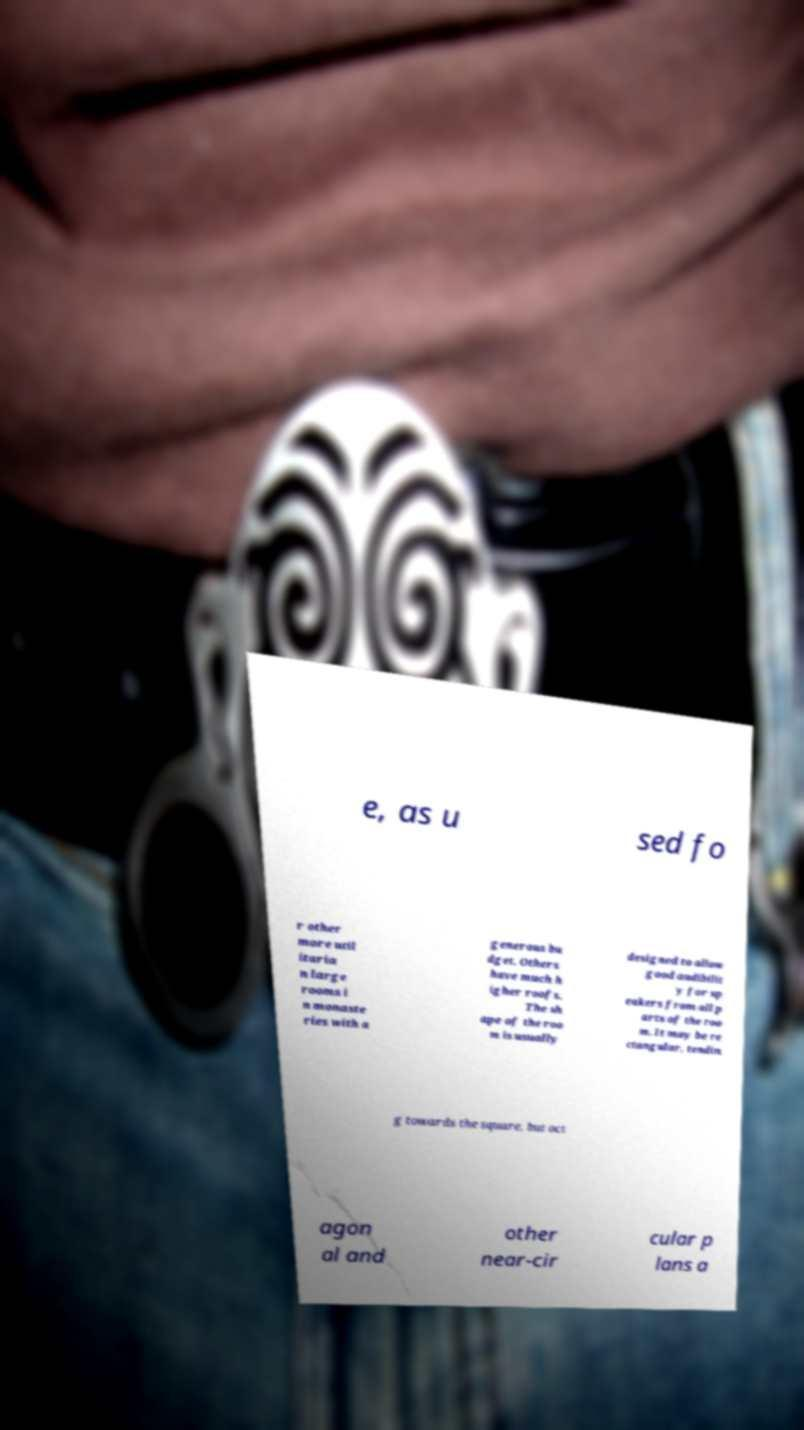I need the written content from this picture converted into text. Can you do that? e, as u sed fo r other more util itaria n large rooms i n monaste ries with a generous bu dget. Others have much h igher roofs. The sh ape of the roo m is usually designed to allow good audibilit y for sp eakers from all p arts of the roo m. It may be re ctangular, tendin g towards the square, but oct agon al and other near-cir cular p lans a 